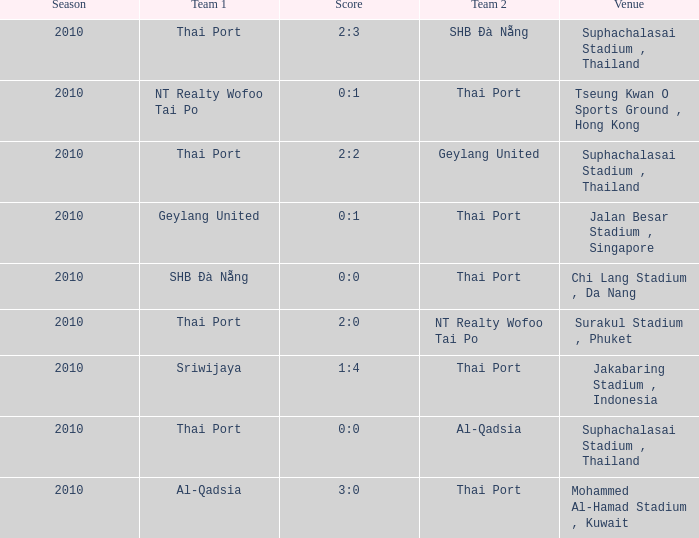What was the tally for the contest involving al-qadsia as the opposing team? 0:0. 